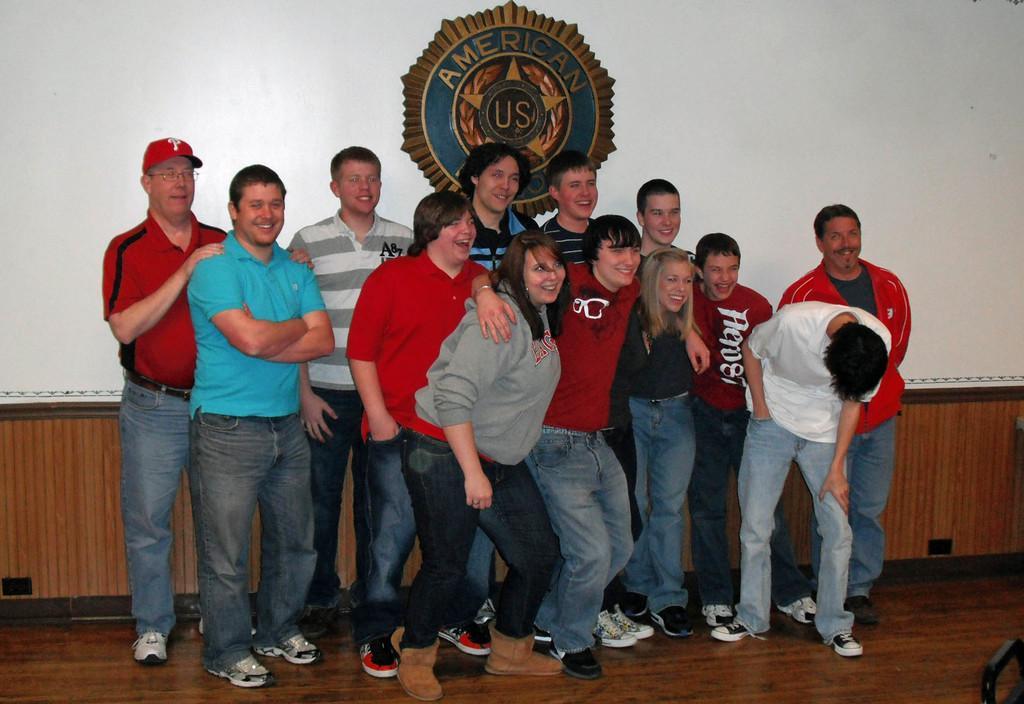Describe this image in one or two sentences. In this picture, we see a group of people are standing. Out of them, we see two women. All of them are standing and they are posing for the photo. Behind them, we see a brown wooden wall and a white wall on which the logo of the organization is placed. At the bottom, we see a wooden wall in brown color. 